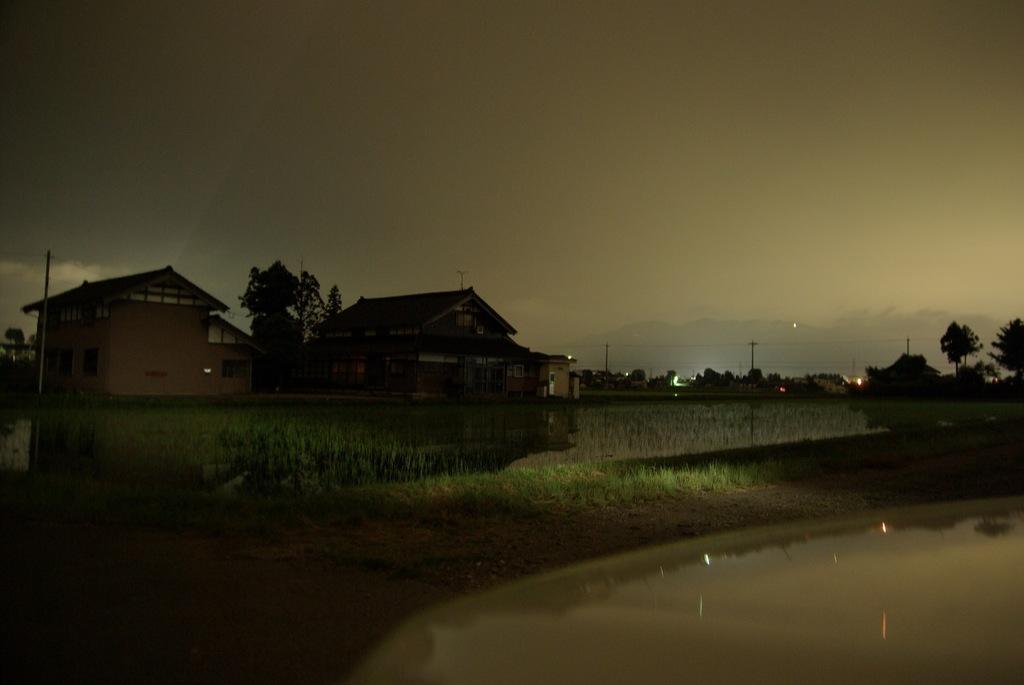Please provide a concise description of this image. In this image we can see some houses with roof. We can also see some grass, water, trees, some utility poles with wires, lights, the hills and the sky which looks cloudy. 